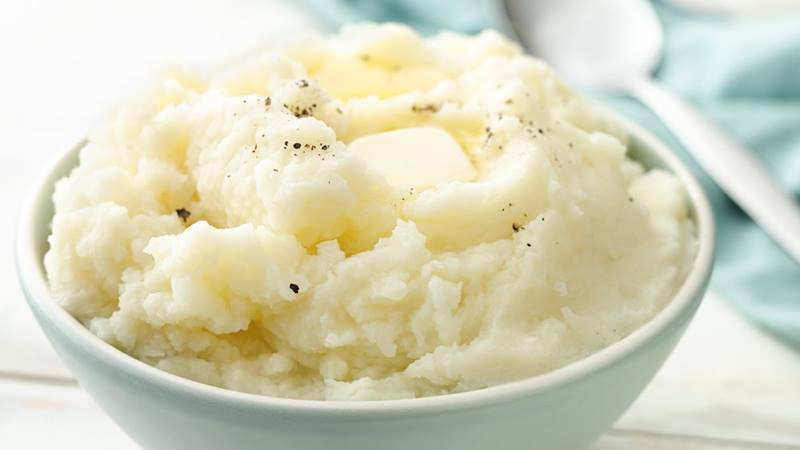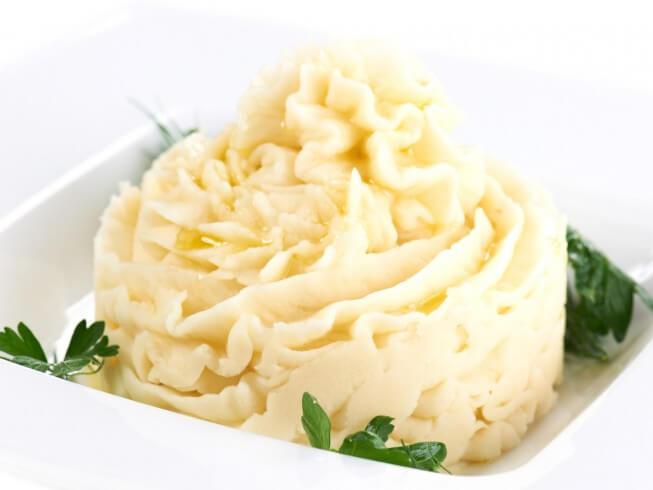The first image is the image on the left, the second image is the image on the right. Evaluate the accuracy of this statement regarding the images: "One image shows mashed potatoes on a squarish plate garnished with green sprig.". Is it true? Answer yes or no. Yes. 